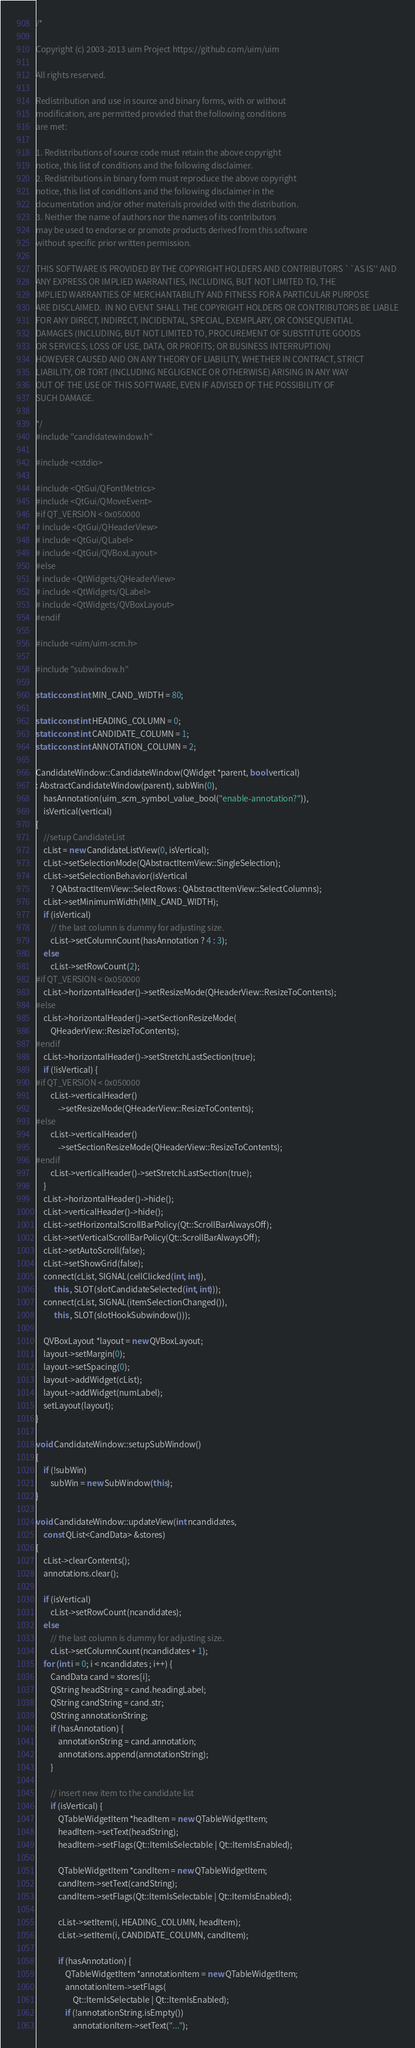Convert code to text. <code><loc_0><loc_0><loc_500><loc_500><_C++_>/*

Copyright (c) 2003-2013 uim Project https://github.com/uim/uim

All rights reserved.

Redistribution and use in source and binary forms, with or without
modification, are permitted provided that the following conditions
are met:

1. Redistributions of source code must retain the above copyright
notice, this list of conditions and the following disclaimer.
2. Redistributions in binary form must reproduce the above copyright
notice, this list of conditions and the following disclaimer in the
documentation and/or other materials provided with the distribution.
3. Neither the name of authors nor the names of its contributors
may be used to endorse or promote products derived from this software
without specific prior written permission.

THIS SOFTWARE IS PROVIDED BY THE COPYRIGHT HOLDERS AND CONTRIBUTORS ``AS IS'' AND
ANY EXPRESS OR IMPLIED WARRANTIES, INCLUDING, BUT NOT LIMITED TO, THE
IMPLIED WARRANTIES OF MERCHANTABILITY AND FITNESS FOR A PARTICULAR PURPOSE
ARE DISCLAIMED.  IN NO EVENT SHALL THE COPYRIGHT HOLDERS OR CONTRIBUTORS BE LIABLE
FOR ANY DIRECT, INDIRECT, INCIDENTAL, SPECIAL, EXEMPLARY, OR CONSEQUENTIAL
DAMAGES (INCLUDING, BUT NOT LIMITED TO, PROCUREMENT OF SUBSTITUTE GOODS
OR SERVICES; LOSS OF USE, DATA, OR PROFITS; OR BUSINESS INTERRUPTION)
HOWEVER CAUSED AND ON ANY THEORY OF LIABILITY, WHETHER IN CONTRACT, STRICT
LIABILITY, OR TORT (INCLUDING NEGLIGENCE OR OTHERWISE) ARISING IN ANY WAY
OUT OF THE USE OF THIS SOFTWARE, EVEN IF ADVISED OF THE POSSIBILITY OF
SUCH DAMAGE.

*/
#include "candidatewindow.h"

#include <cstdio>

#include <QtGui/QFontMetrics>
#include <QtGui/QMoveEvent>
#if QT_VERSION < 0x050000
# include <QtGui/QHeaderView>
# include <QtGui/QLabel>
# include <QtGui/QVBoxLayout>
#else
# include <QtWidgets/QHeaderView>
# include <QtWidgets/QLabel>
# include <QtWidgets/QVBoxLayout>
#endif

#include <uim/uim-scm.h>

#include "subwindow.h"

static const int MIN_CAND_WIDTH = 80;

static const int HEADING_COLUMN = 0;
static const int CANDIDATE_COLUMN = 1;
static const int ANNOTATION_COLUMN = 2;

CandidateWindow::CandidateWindow(QWidget *parent, bool vertical)
: AbstractCandidateWindow(parent), subWin(0),
    hasAnnotation(uim_scm_symbol_value_bool("enable-annotation?")),
    isVertical(vertical)
{
    //setup CandidateList
    cList = new CandidateListView(0, isVertical);
    cList->setSelectionMode(QAbstractItemView::SingleSelection);
    cList->setSelectionBehavior(isVertical
        ? QAbstractItemView::SelectRows : QAbstractItemView::SelectColumns);
    cList->setMinimumWidth(MIN_CAND_WIDTH);
    if (isVertical)
        // the last column is dummy for adjusting size.
        cList->setColumnCount(hasAnnotation ? 4 : 3);
    else
        cList->setRowCount(2);
#if QT_VERSION < 0x050000
    cList->horizontalHeader()->setResizeMode(QHeaderView::ResizeToContents);
#else
    cList->horizontalHeader()->setSectionResizeMode(
        QHeaderView::ResizeToContents);
#endif
    cList->horizontalHeader()->setStretchLastSection(true);
    if (!isVertical) {
#if QT_VERSION < 0x050000
        cList->verticalHeader()
            ->setResizeMode(QHeaderView::ResizeToContents);
#else
        cList->verticalHeader()
            ->setSectionResizeMode(QHeaderView::ResizeToContents);
#endif
        cList->verticalHeader()->setStretchLastSection(true);
    }
    cList->horizontalHeader()->hide();
    cList->verticalHeader()->hide();
    cList->setHorizontalScrollBarPolicy(Qt::ScrollBarAlwaysOff);
    cList->setVerticalScrollBarPolicy(Qt::ScrollBarAlwaysOff);
    cList->setAutoScroll(false);
    cList->setShowGrid(false);
    connect(cList, SIGNAL(cellClicked(int, int)),
          this , SLOT(slotCandidateSelected(int, int)));
    connect(cList, SIGNAL(itemSelectionChanged()),
          this , SLOT(slotHookSubwindow()));

    QVBoxLayout *layout = new QVBoxLayout;
    layout->setMargin(0);
    layout->setSpacing(0);
    layout->addWidget(cList);
    layout->addWidget(numLabel);
    setLayout(layout);
}

void CandidateWindow::setupSubWindow()
{
    if (!subWin)
        subWin = new SubWindow(this);
}

void CandidateWindow::updateView(int ncandidates,
    const QList<CandData> &stores)
{
    cList->clearContents();
    annotations.clear();

    if (isVertical)
        cList->setRowCount(ncandidates);
    else
        // the last column is dummy for adjusting size.
        cList->setColumnCount(ncandidates + 1);
    for (int i = 0; i < ncandidates ; i++) {
        CandData cand = stores[i];
        QString headString = cand.headingLabel;
        QString candString = cand.str;
        QString annotationString;
        if (hasAnnotation) {
            annotationString = cand.annotation;
            annotations.append(annotationString);
        }

        // insert new item to the candidate list
        if (isVertical) {
            QTableWidgetItem *headItem = new QTableWidgetItem;
            headItem->setText(headString);
            headItem->setFlags(Qt::ItemIsSelectable | Qt::ItemIsEnabled);

            QTableWidgetItem *candItem = new QTableWidgetItem;
            candItem->setText(candString);
            candItem->setFlags(Qt::ItemIsSelectable | Qt::ItemIsEnabled);

            cList->setItem(i, HEADING_COLUMN, headItem);
            cList->setItem(i, CANDIDATE_COLUMN, candItem);

            if (hasAnnotation) {
                QTableWidgetItem *annotationItem = new QTableWidgetItem;
                annotationItem->setFlags(
                    Qt::ItemIsSelectable | Qt::ItemIsEnabled);
                if (!annotationString.isEmpty())
                    annotationItem->setText("...");
</code> 